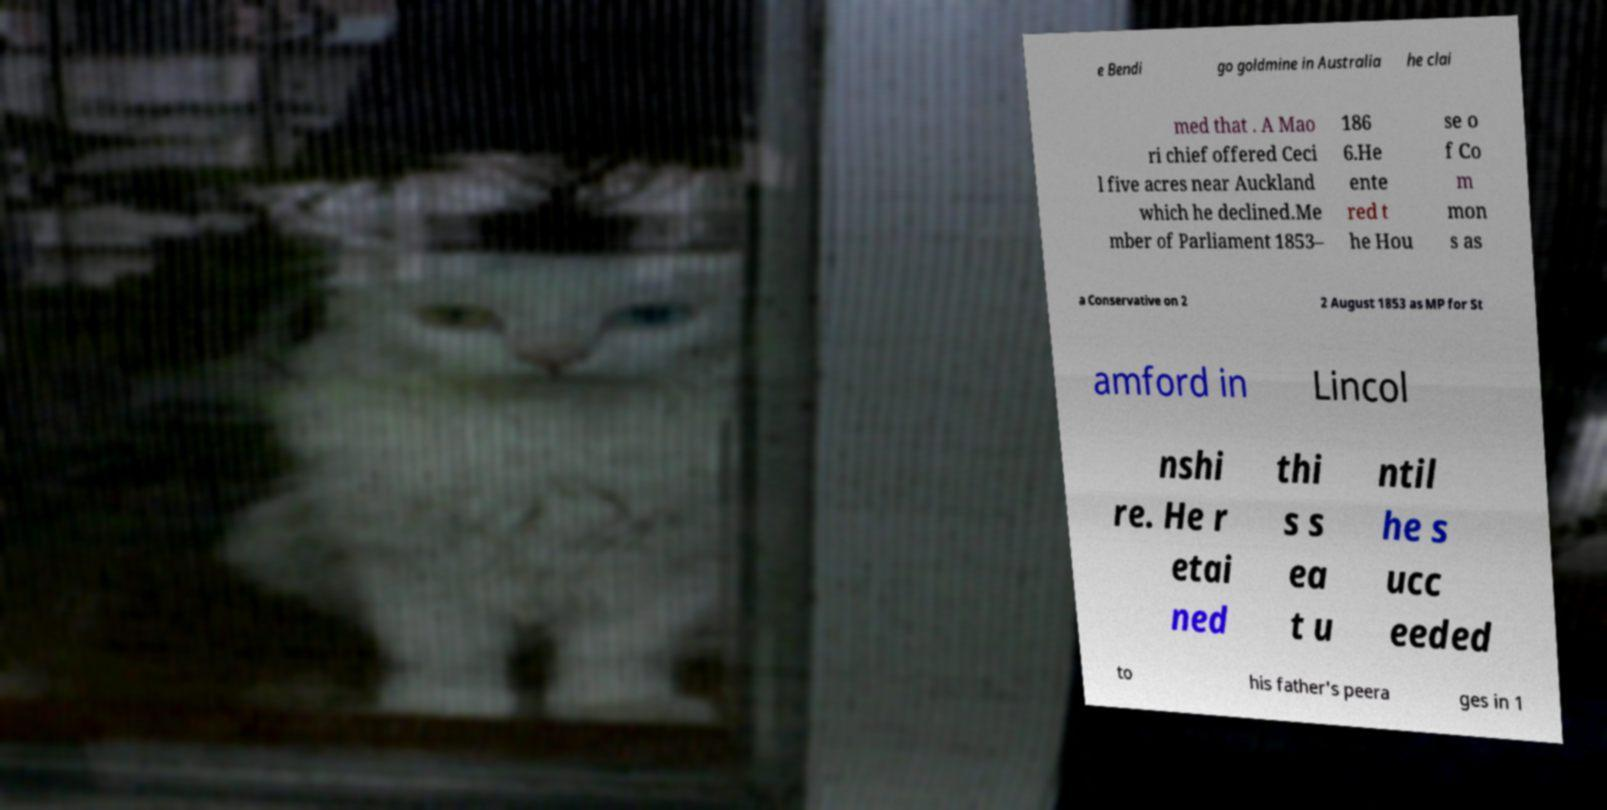Could you assist in decoding the text presented in this image and type it out clearly? e Bendi go goldmine in Australia he clai med that . A Mao ri chief offered Ceci l five acres near Auckland which he declined.Me mber of Parliament 1853– 186 6.He ente red t he Hou se o f Co m mon s as a Conservative on 2 2 August 1853 as MP for St amford in Lincol nshi re. He r etai ned thi s s ea t u ntil he s ucc eeded to his father's peera ges in 1 